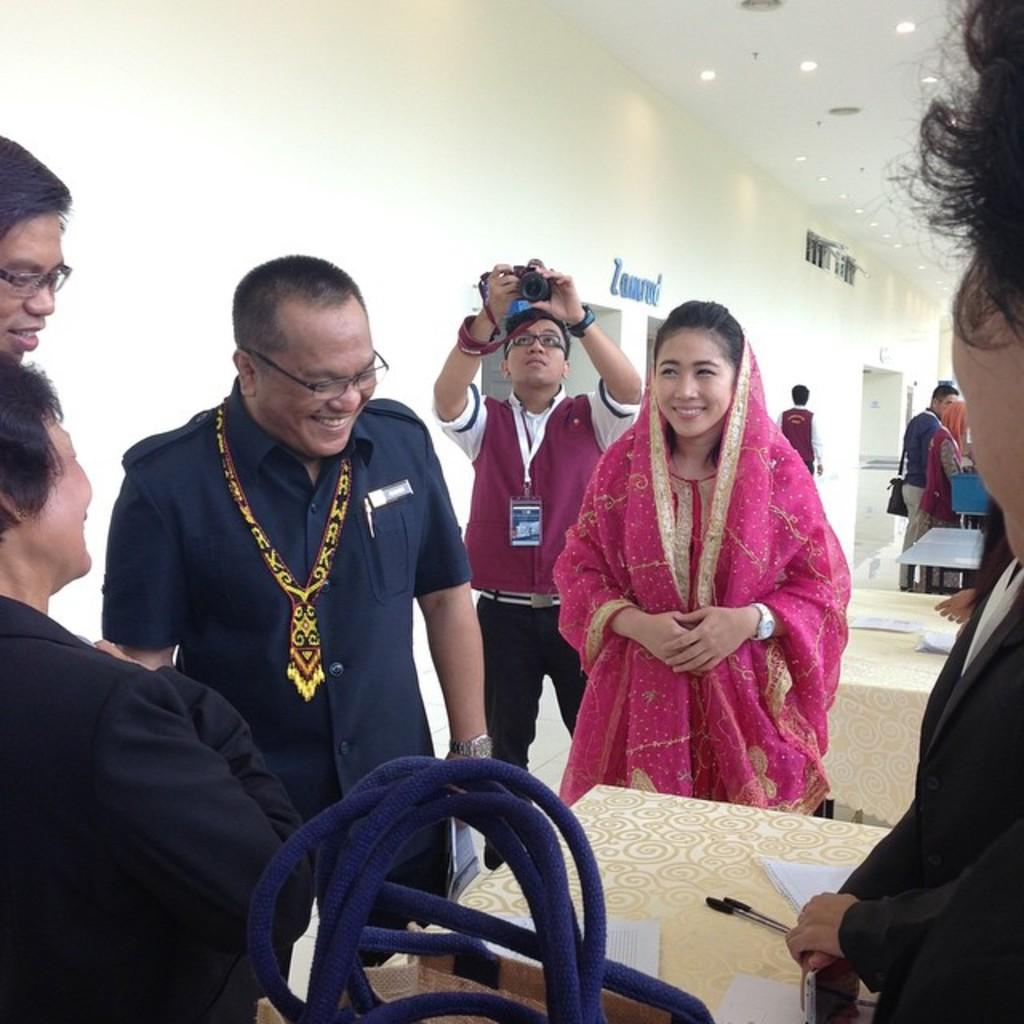What is the general expression of the people in the image? The people in the image have smiles on their faces. What are the people doing in the image? The people are standing on a surface. Can you identify any person holding an object in the image? Yes, there is a person holding a camera in the image. What is present on the roof in the image? There are light arrangements on the roof. What type of furniture is visible in the image? There is a table in the image. What type of tail can be seen on the person holding the camera in the image? There is no tail visible on the person holding the camera in the image. What type of stove is present in the image? There is no stove present in the image. 